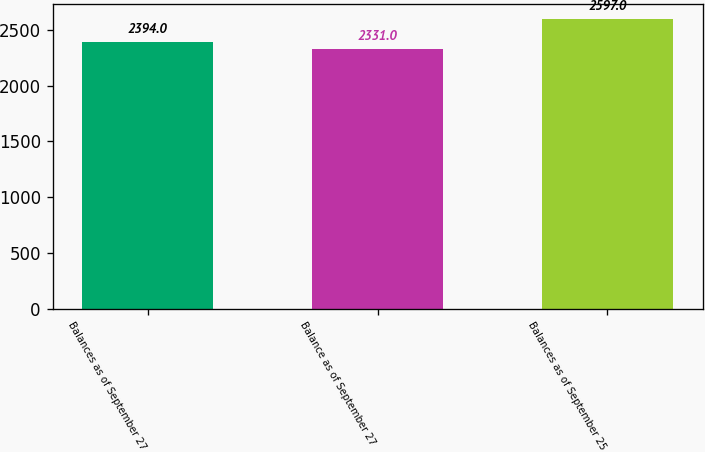Convert chart. <chart><loc_0><loc_0><loc_500><loc_500><bar_chart><fcel>Balances as of September 27<fcel>Balance as of September 27<fcel>Balances as of September 25<nl><fcel>2394<fcel>2331<fcel>2597<nl></chart> 